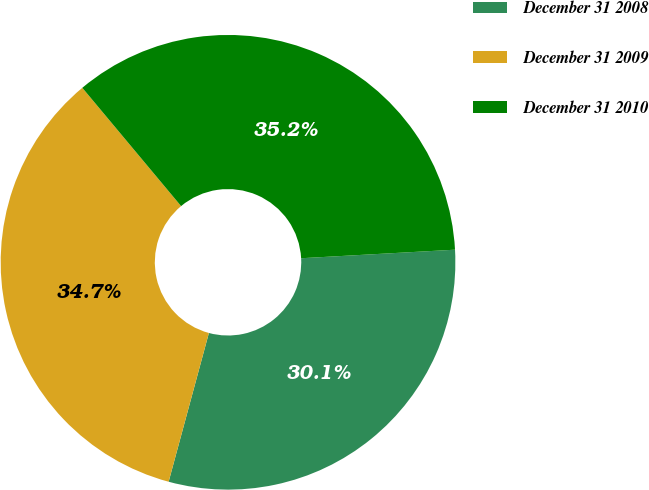Convert chart. <chart><loc_0><loc_0><loc_500><loc_500><pie_chart><fcel>December 31 2008<fcel>December 31 2009<fcel>December 31 2010<nl><fcel>30.09%<fcel>34.72%<fcel>35.19%<nl></chart> 